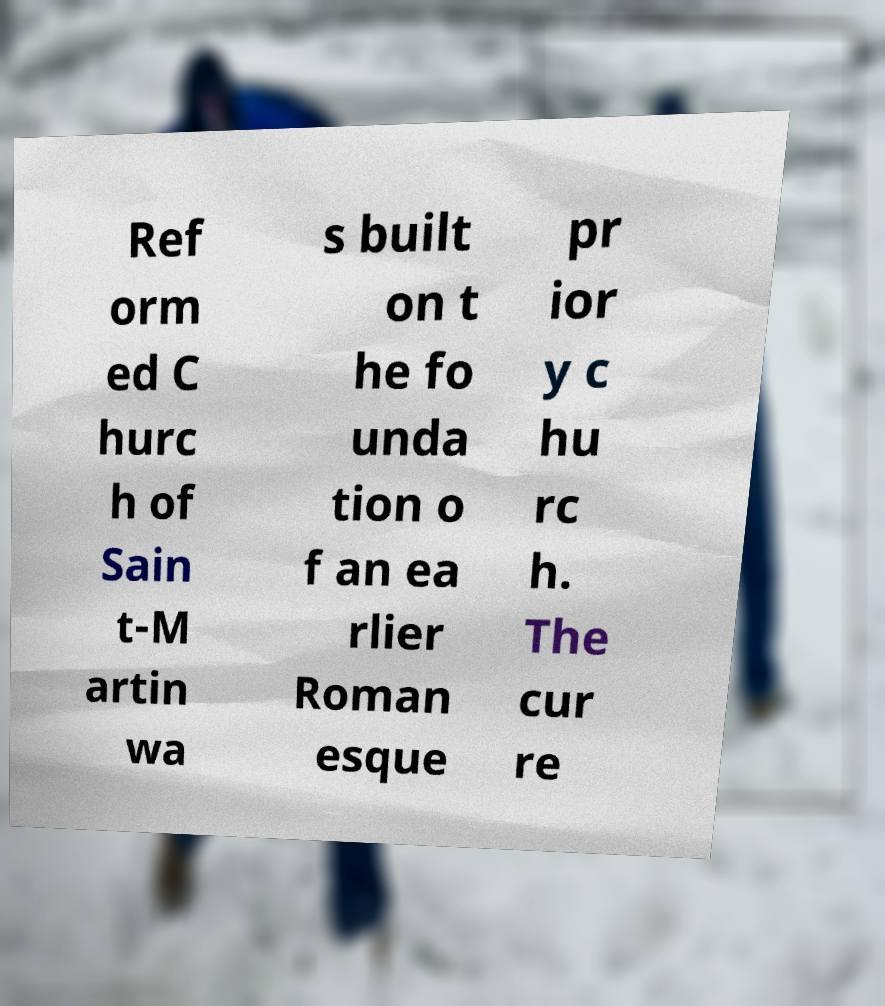I need the written content from this picture converted into text. Can you do that? Ref orm ed C hurc h of Sain t-M artin wa s built on t he fo unda tion o f an ea rlier Roman esque pr ior y c hu rc h. The cur re 